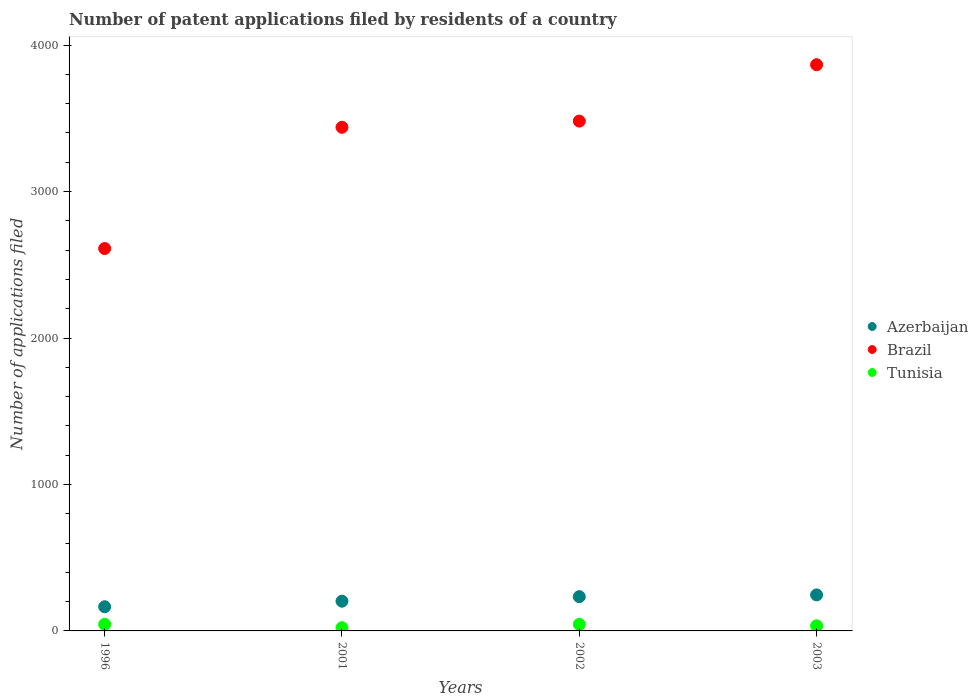What is the number of applications filed in Azerbaijan in 2001?
Your answer should be very brief. 203. Across all years, what is the maximum number of applications filed in Brazil?
Your answer should be very brief. 3866. Across all years, what is the minimum number of applications filed in Brazil?
Offer a very short reply. 2611. In which year was the number of applications filed in Azerbaijan maximum?
Your answer should be compact. 2003. In which year was the number of applications filed in Brazil minimum?
Make the answer very short. 1996. What is the total number of applications filed in Brazil in the graph?
Provide a short and direct response. 1.34e+04. What is the difference between the number of applications filed in Brazil in 2002 and the number of applications filed in Azerbaijan in 2001?
Ensure brevity in your answer.  3278. What is the average number of applications filed in Azerbaijan per year?
Your answer should be compact. 212. In the year 2003, what is the difference between the number of applications filed in Azerbaijan and number of applications filed in Brazil?
Give a very brief answer. -3620. What is the ratio of the number of applications filed in Azerbaijan in 1996 to that in 2003?
Your response must be concise. 0.67. Is the difference between the number of applications filed in Azerbaijan in 1996 and 2002 greater than the difference between the number of applications filed in Brazil in 1996 and 2002?
Your answer should be compact. Yes. In how many years, is the number of applications filed in Tunisia greater than the average number of applications filed in Tunisia taken over all years?
Keep it short and to the point. 2. Is the sum of the number of applications filed in Brazil in 2002 and 2003 greater than the maximum number of applications filed in Tunisia across all years?
Your answer should be very brief. Yes. Does the number of applications filed in Brazil monotonically increase over the years?
Your response must be concise. Yes. Is the number of applications filed in Azerbaijan strictly greater than the number of applications filed in Brazil over the years?
Offer a very short reply. No. Is the number of applications filed in Tunisia strictly less than the number of applications filed in Azerbaijan over the years?
Your answer should be very brief. Yes. How many dotlines are there?
Your answer should be compact. 3. How many years are there in the graph?
Your response must be concise. 4. What is the difference between two consecutive major ticks on the Y-axis?
Offer a terse response. 1000. Are the values on the major ticks of Y-axis written in scientific E-notation?
Ensure brevity in your answer.  No. Does the graph contain any zero values?
Provide a succinct answer. No. Does the graph contain grids?
Ensure brevity in your answer.  No. What is the title of the graph?
Offer a terse response. Number of patent applications filed by residents of a country. What is the label or title of the X-axis?
Your response must be concise. Years. What is the label or title of the Y-axis?
Your response must be concise. Number of applications filed. What is the Number of applications filed of Azerbaijan in 1996?
Offer a terse response. 165. What is the Number of applications filed of Brazil in 1996?
Your answer should be compact. 2611. What is the Number of applications filed of Tunisia in 1996?
Your answer should be very brief. 45. What is the Number of applications filed of Azerbaijan in 2001?
Keep it short and to the point. 203. What is the Number of applications filed of Brazil in 2001?
Ensure brevity in your answer.  3439. What is the Number of applications filed in Tunisia in 2001?
Offer a very short reply. 22. What is the Number of applications filed of Azerbaijan in 2002?
Your answer should be very brief. 234. What is the Number of applications filed in Brazil in 2002?
Your answer should be compact. 3481. What is the Number of applications filed in Tunisia in 2002?
Your response must be concise. 45. What is the Number of applications filed of Azerbaijan in 2003?
Offer a terse response. 246. What is the Number of applications filed of Brazil in 2003?
Your response must be concise. 3866. What is the Number of applications filed of Tunisia in 2003?
Your answer should be very brief. 35. Across all years, what is the maximum Number of applications filed in Azerbaijan?
Provide a succinct answer. 246. Across all years, what is the maximum Number of applications filed of Brazil?
Provide a succinct answer. 3866. Across all years, what is the minimum Number of applications filed of Azerbaijan?
Your response must be concise. 165. Across all years, what is the minimum Number of applications filed in Brazil?
Provide a succinct answer. 2611. Across all years, what is the minimum Number of applications filed in Tunisia?
Provide a succinct answer. 22. What is the total Number of applications filed of Azerbaijan in the graph?
Your answer should be compact. 848. What is the total Number of applications filed in Brazil in the graph?
Provide a short and direct response. 1.34e+04. What is the total Number of applications filed of Tunisia in the graph?
Provide a short and direct response. 147. What is the difference between the Number of applications filed in Azerbaijan in 1996 and that in 2001?
Keep it short and to the point. -38. What is the difference between the Number of applications filed of Brazil in 1996 and that in 2001?
Ensure brevity in your answer.  -828. What is the difference between the Number of applications filed of Azerbaijan in 1996 and that in 2002?
Your answer should be very brief. -69. What is the difference between the Number of applications filed in Brazil in 1996 and that in 2002?
Ensure brevity in your answer.  -870. What is the difference between the Number of applications filed in Azerbaijan in 1996 and that in 2003?
Your answer should be very brief. -81. What is the difference between the Number of applications filed in Brazil in 1996 and that in 2003?
Offer a very short reply. -1255. What is the difference between the Number of applications filed of Azerbaijan in 2001 and that in 2002?
Make the answer very short. -31. What is the difference between the Number of applications filed of Brazil in 2001 and that in 2002?
Your response must be concise. -42. What is the difference between the Number of applications filed in Azerbaijan in 2001 and that in 2003?
Make the answer very short. -43. What is the difference between the Number of applications filed in Brazil in 2001 and that in 2003?
Give a very brief answer. -427. What is the difference between the Number of applications filed of Azerbaijan in 2002 and that in 2003?
Keep it short and to the point. -12. What is the difference between the Number of applications filed in Brazil in 2002 and that in 2003?
Provide a short and direct response. -385. What is the difference between the Number of applications filed in Azerbaijan in 1996 and the Number of applications filed in Brazil in 2001?
Give a very brief answer. -3274. What is the difference between the Number of applications filed of Azerbaijan in 1996 and the Number of applications filed of Tunisia in 2001?
Provide a succinct answer. 143. What is the difference between the Number of applications filed in Brazil in 1996 and the Number of applications filed in Tunisia in 2001?
Offer a very short reply. 2589. What is the difference between the Number of applications filed of Azerbaijan in 1996 and the Number of applications filed of Brazil in 2002?
Provide a short and direct response. -3316. What is the difference between the Number of applications filed of Azerbaijan in 1996 and the Number of applications filed of Tunisia in 2002?
Keep it short and to the point. 120. What is the difference between the Number of applications filed of Brazil in 1996 and the Number of applications filed of Tunisia in 2002?
Ensure brevity in your answer.  2566. What is the difference between the Number of applications filed of Azerbaijan in 1996 and the Number of applications filed of Brazil in 2003?
Make the answer very short. -3701. What is the difference between the Number of applications filed of Azerbaijan in 1996 and the Number of applications filed of Tunisia in 2003?
Give a very brief answer. 130. What is the difference between the Number of applications filed of Brazil in 1996 and the Number of applications filed of Tunisia in 2003?
Offer a terse response. 2576. What is the difference between the Number of applications filed in Azerbaijan in 2001 and the Number of applications filed in Brazil in 2002?
Make the answer very short. -3278. What is the difference between the Number of applications filed in Azerbaijan in 2001 and the Number of applications filed in Tunisia in 2002?
Provide a succinct answer. 158. What is the difference between the Number of applications filed in Brazil in 2001 and the Number of applications filed in Tunisia in 2002?
Ensure brevity in your answer.  3394. What is the difference between the Number of applications filed in Azerbaijan in 2001 and the Number of applications filed in Brazil in 2003?
Ensure brevity in your answer.  -3663. What is the difference between the Number of applications filed of Azerbaijan in 2001 and the Number of applications filed of Tunisia in 2003?
Make the answer very short. 168. What is the difference between the Number of applications filed in Brazil in 2001 and the Number of applications filed in Tunisia in 2003?
Keep it short and to the point. 3404. What is the difference between the Number of applications filed of Azerbaijan in 2002 and the Number of applications filed of Brazil in 2003?
Offer a terse response. -3632. What is the difference between the Number of applications filed in Azerbaijan in 2002 and the Number of applications filed in Tunisia in 2003?
Your response must be concise. 199. What is the difference between the Number of applications filed of Brazil in 2002 and the Number of applications filed of Tunisia in 2003?
Ensure brevity in your answer.  3446. What is the average Number of applications filed in Azerbaijan per year?
Ensure brevity in your answer.  212. What is the average Number of applications filed in Brazil per year?
Give a very brief answer. 3349.25. What is the average Number of applications filed in Tunisia per year?
Your answer should be very brief. 36.75. In the year 1996, what is the difference between the Number of applications filed in Azerbaijan and Number of applications filed in Brazil?
Your answer should be compact. -2446. In the year 1996, what is the difference between the Number of applications filed in Azerbaijan and Number of applications filed in Tunisia?
Your answer should be very brief. 120. In the year 1996, what is the difference between the Number of applications filed of Brazil and Number of applications filed of Tunisia?
Your answer should be compact. 2566. In the year 2001, what is the difference between the Number of applications filed of Azerbaijan and Number of applications filed of Brazil?
Ensure brevity in your answer.  -3236. In the year 2001, what is the difference between the Number of applications filed of Azerbaijan and Number of applications filed of Tunisia?
Provide a short and direct response. 181. In the year 2001, what is the difference between the Number of applications filed of Brazil and Number of applications filed of Tunisia?
Your response must be concise. 3417. In the year 2002, what is the difference between the Number of applications filed in Azerbaijan and Number of applications filed in Brazil?
Provide a short and direct response. -3247. In the year 2002, what is the difference between the Number of applications filed of Azerbaijan and Number of applications filed of Tunisia?
Keep it short and to the point. 189. In the year 2002, what is the difference between the Number of applications filed in Brazil and Number of applications filed in Tunisia?
Provide a succinct answer. 3436. In the year 2003, what is the difference between the Number of applications filed of Azerbaijan and Number of applications filed of Brazil?
Provide a succinct answer. -3620. In the year 2003, what is the difference between the Number of applications filed in Azerbaijan and Number of applications filed in Tunisia?
Offer a terse response. 211. In the year 2003, what is the difference between the Number of applications filed in Brazil and Number of applications filed in Tunisia?
Offer a terse response. 3831. What is the ratio of the Number of applications filed in Azerbaijan in 1996 to that in 2001?
Ensure brevity in your answer.  0.81. What is the ratio of the Number of applications filed of Brazil in 1996 to that in 2001?
Offer a very short reply. 0.76. What is the ratio of the Number of applications filed in Tunisia in 1996 to that in 2001?
Offer a very short reply. 2.05. What is the ratio of the Number of applications filed of Azerbaijan in 1996 to that in 2002?
Provide a short and direct response. 0.71. What is the ratio of the Number of applications filed in Brazil in 1996 to that in 2002?
Give a very brief answer. 0.75. What is the ratio of the Number of applications filed in Tunisia in 1996 to that in 2002?
Give a very brief answer. 1. What is the ratio of the Number of applications filed of Azerbaijan in 1996 to that in 2003?
Your answer should be compact. 0.67. What is the ratio of the Number of applications filed of Brazil in 1996 to that in 2003?
Keep it short and to the point. 0.68. What is the ratio of the Number of applications filed of Azerbaijan in 2001 to that in 2002?
Keep it short and to the point. 0.87. What is the ratio of the Number of applications filed in Brazil in 2001 to that in 2002?
Provide a short and direct response. 0.99. What is the ratio of the Number of applications filed in Tunisia in 2001 to that in 2002?
Keep it short and to the point. 0.49. What is the ratio of the Number of applications filed in Azerbaijan in 2001 to that in 2003?
Your answer should be very brief. 0.83. What is the ratio of the Number of applications filed of Brazil in 2001 to that in 2003?
Make the answer very short. 0.89. What is the ratio of the Number of applications filed in Tunisia in 2001 to that in 2003?
Offer a terse response. 0.63. What is the ratio of the Number of applications filed in Azerbaijan in 2002 to that in 2003?
Your answer should be compact. 0.95. What is the ratio of the Number of applications filed in Brazil in 2002 to that in 2003?
Make the answer very short. 0.9. What is the difference between the highest and the second highest Number of applications filed of Azerbaijan?
Your answer should be very brief. 12. What is the difference between the highest and the second highest Number of applications filed of Brazil?
Offer a very short reply. 385. What is the difference between the highest and the second highest Number of applications filed in Tunisia?
Your answer should be compact. 0. What is the difference between the highest and the lowest Number of applications filed in Azerbaijan?
Your response must be concise. 81. What is the difference between the highest and the lowest Number of applications filed of Brazil?
Your answer should be very brief. 1255. 